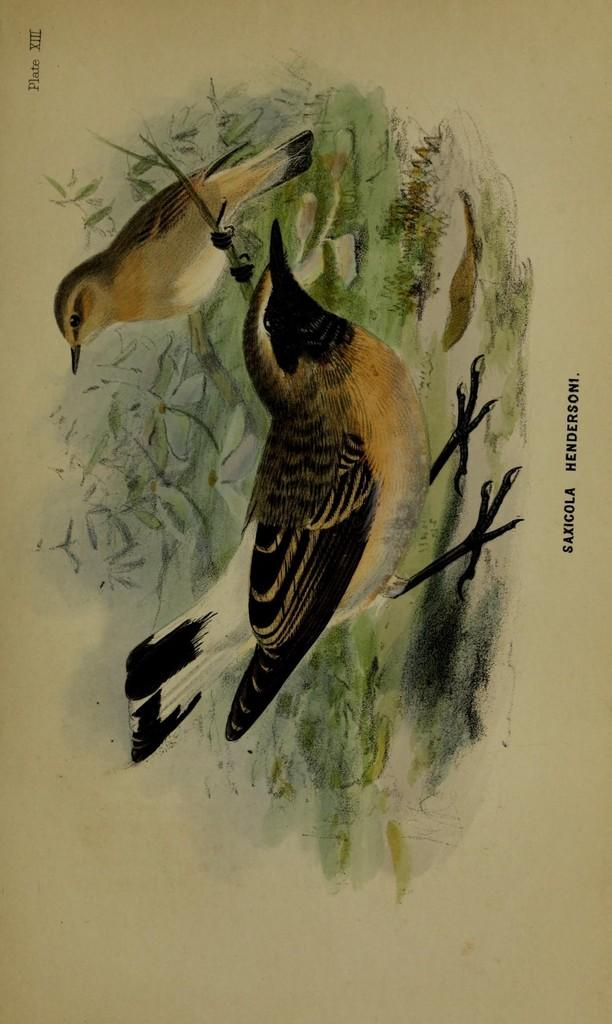What is the main subject of the image? The main subject of the image is bird art. Can you describe any text present in the image? Yes, there is text on the right side of the image. What color is the twist in the image? There is no twist present in the image; it features bird art and text. 